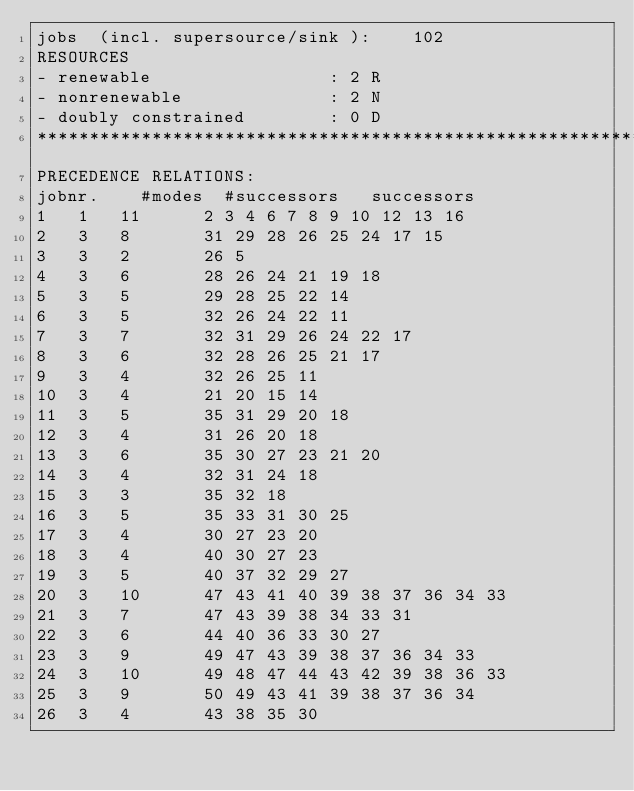<code> <loc_0><loc_0><loc_500><loc_500><_ObjectiveC_>jobs  (incl. supersource/sink ):	102
RESOURCES
- renewable                 : 2 R
- nonrenewable              : 2 N
- doubly constrained        : 0 D
************************************************************************
PRECEDENCE RELATIONS:
jobnr.    #modes  #successors   successors
1	1	11		2 3 4 6 7 8 9 10 12 13 16 
2	3	8		31 29 28 26 25 24 17 15 
3	3	2		26 5 
4	3	6		28 26 24 21 19 18 
5	3	5		29 28 25 22 14 
6	3	5		32 26 24 22 11 
7	3	7		32 31 29 26 24 22 17 
8	3	6		32 28 26 25 21 17 
9	3	4		32 26 25 11 
10	3	4		21 20 15 14 
11	3	5		35 31 29 20 18 
12	3	4		31 26 20 18 
13	3	6		35 30 27 23 21 20 
14	3	4		32 31 24 18 
15	3	3		35 32 18 
16	3	5		35 33 31 30 25 
17	3	4		30 27 23 20 
18	3	4		40 30 27 23 
19	3	5		40 37 32 29 27 
20	3	10		47 43 41 40 39 38 37 36 34 33 
21	3	7		47 43 39 38 34 33 31 
22	3	6		44 40 36 33 30 27 
23	3	9		49 47 43 39 38 37 36 34 33 
24	3	10		49 48 47 44 43 42 39 38 36 33 
25	3	9		50 49 43 41 39 38 37 36 34 
26	3	4		43 38 35 30 </code> 